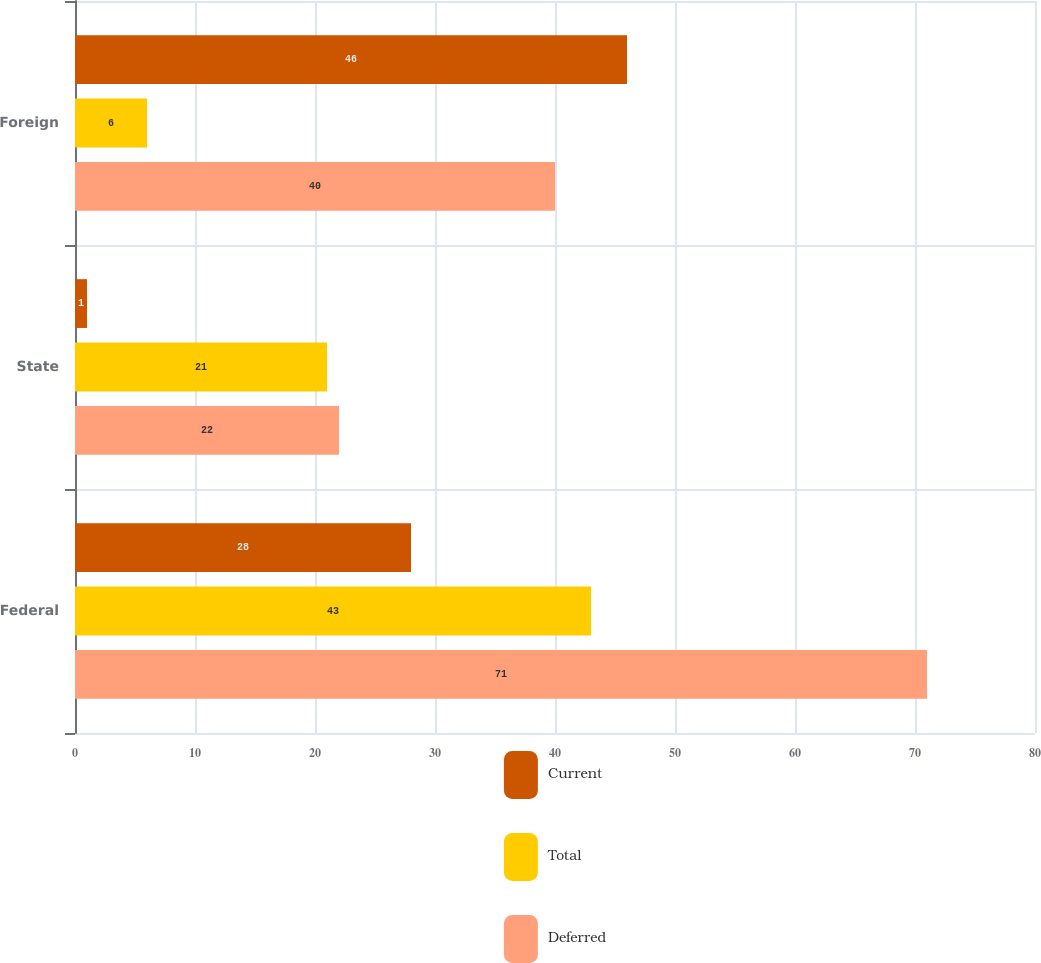Convert chart. <chart><loc_0><loc_0><loc_500><loc_500><stacked_bar_chart><ecel><fcel>Federal<fcel>State<fcel>Foreign<nl><fcel>Current<fcel>28<fcel>1<fcel>46<nl><fcel>Total<fcel>43<fcel>21<fcel>6<nl><fcel>Deferred<fcel>71<fcel>22<fcel>40<nl></chart> 